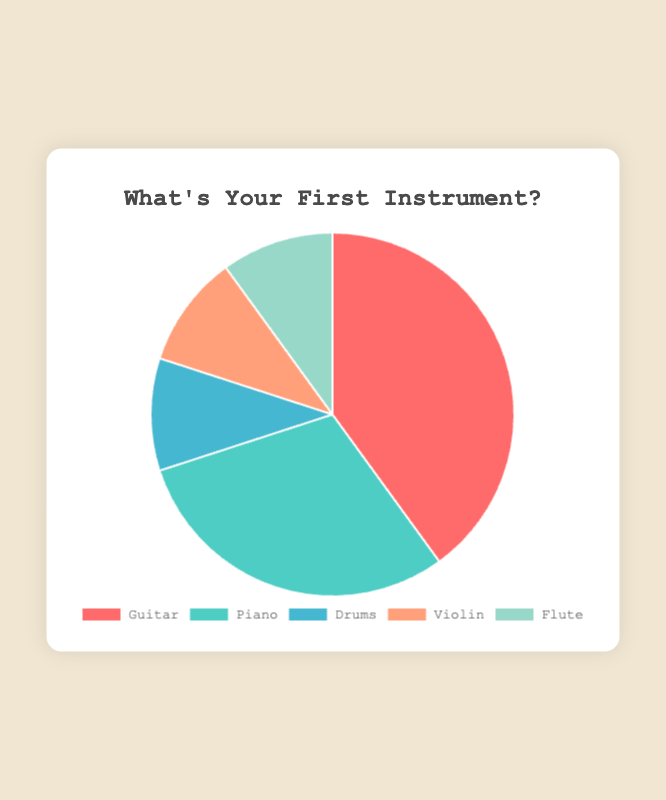Which instrument is most preferred among beginners? By looking at the pie chart, the largest section represents the Guitar with a 40% share.
Answer: Guitar Which instruments have the same percentage of beginners? The pie chart shows that Drums, Violin, and Flute each have a 10% share.
Answer: Drums, Violin, Flute How much more preferred is the Guitar compared to the Piano? Guitar has a 40% share while Piano has a 30% share. The difference between them is 40% - 30% = 10%.
Answer: 10% Between Guitar, Piano, and Drums, which has the smallest share? Among Guitar (40%), Piano (30%), and Drums (10%), Drums has the smallest share.
Answer: Drums What is the total percentage of beginners who prefer Drums, Violin, and Flute combined? The percentage of each is Drums: 10%, Violin: 10%, Flute: 10%. The total is 10% + 10% + 10% = 30%.
Answer: 30% What fraction of beginners prefer either Violin or Flute? Both Violin and Flute have a 10% share each. The combined share is 10% + 10% = 20%. Thus, the fraction is 20/100 or 1/5.
Answer: 1/5 Is the preference for Guitar greater than the sum of preferences for Piano and Drums? Guitar has 40%, and the sum of Piano (30%) and Drums (10%) is 30% + 10% = 40%. Since 40% is equal to 40%, the preference for Guitar is not greater but equal.
Answer: No Which instrument is represented by the teal section of the pie chart? The teal section represents the Piano with a 30% share, as indicated by the legend.
Answer: Piano 